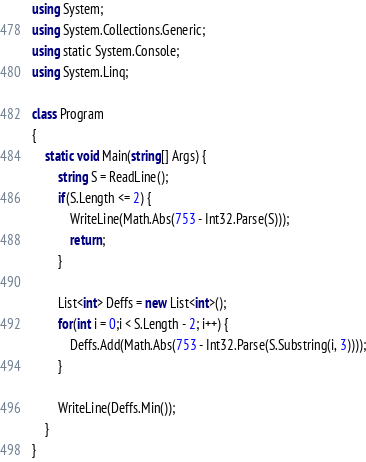Convert code to text. <code><loc_0><loc_0><loc_500><loc_500><_C#_>using System;
using System.Collections.Generic;
using static System.Console;
using System.Linq;

class Program
{
    static void Main(string[] Args) {
        string S = ReadLine();
        if(S.Length <= 2) {
            WriteLine(Math.Abs(753 - Int32.Parse(S)));
            return;
        }

        List<int> Deffs = new List<int>();
        for(int i = 0;i < S.Length - 2; i++) {
            Deffs.Add(Math.Abs(753 - Int32.Parse(S.Substring(i, 3))));
        }

        WriteLine(Deffs.Min());
    }
}</code> 